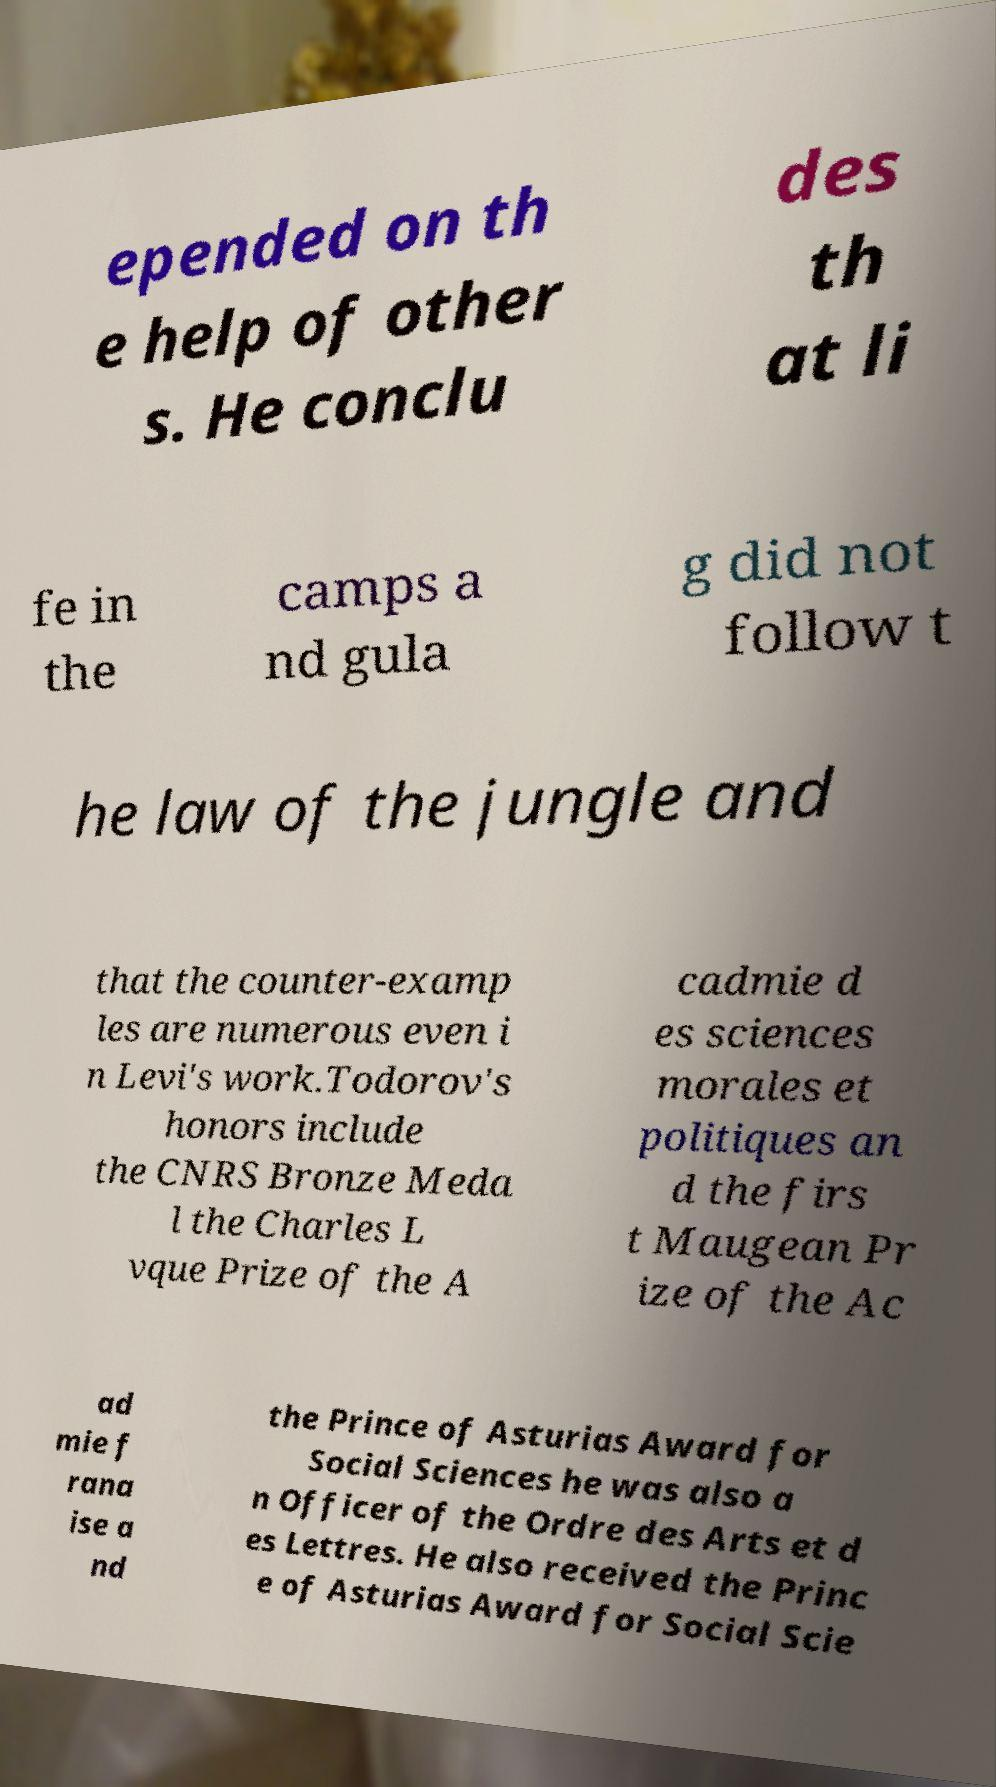Please read and relay the text visible in this image. What does it say? epended on th e help of other s. He conclu des th at li fe in the camps a nd gula g did not follow t he law of the jungle and that the counter-examp les are numerous even i n Levi's work.Todorov's honors include the CNRS Bronze Meda l the Charles L vque Prize of the A cadmie d es sciences morales et politiques an d the firs t Maugean Pr ize of the Ac ad mie f rana ise a nd the Prince of Asturias Award for Social Sciences he was also a n Officer of the Ordre des Arts et d es Lettres. He also received the Princ e of Asturias Award for Social Scie 